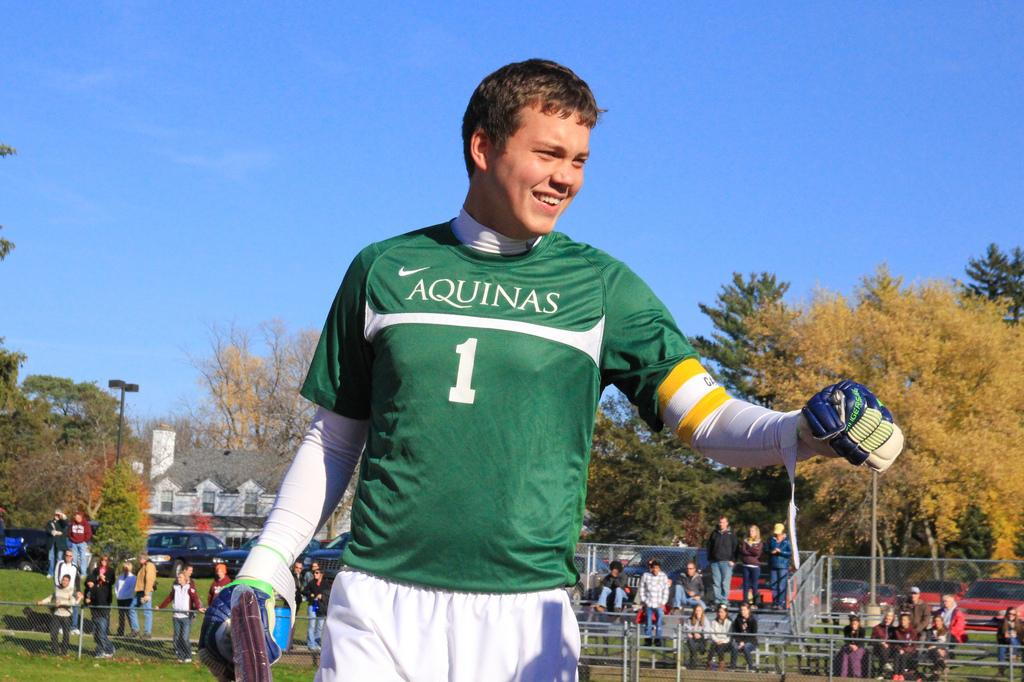<image>
Describe the image concisely. A player on the field wears a green shirt that has the word Aquinas on it. 